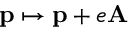<formula> <loc_0><loc_0><loc_500><loc_500>p \mapsto p + e A</formula> 